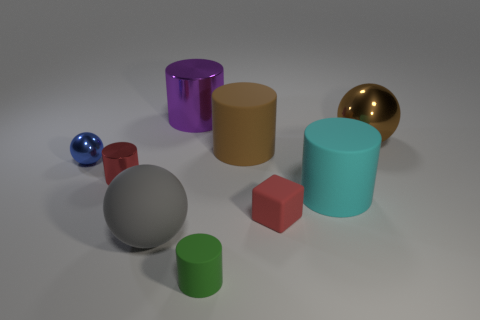Are there fewer large purple cylinders right of the large purple metallic cylinder than green cylinders behind the gray thing?
Your response must be concise. No. What number of other things are there of the same size as the green object?
Keep it short and to the point. 3. There is a small metal object in front of the small shiny thing that is behind the tiny red object that is to the left of the large purple metallic cylinder; what shape is it?
Ensure brevity in your answer.  Cylinder. How many brown things are either tiny objects or tiny rubber things?
Keep it short and to the point. 0. There is a small cylinder behind the gray matte ball; how many gray matte objects are on the left side of it?
Provide a short and direct response. 0. Is there any other thing that has the same color as the large rubber sphere?
Keep it short and to the point. No. What shape is the blue object that is the same material as the red cylinder?
Your response must be concise. Sphere. Is the rubber ball the same color as the small shiny cylinder?
Provide a short and direct response. No. Are the brown thing on the left side of the big cyan rubber thing and the object in front of the gray matte ball made of the same material?
Provide a succinct answer. Yes. What number of things are either large cyan things or shiny spheres on the left side of the large cyan matte object?
Provide a short and direct response. 2. 